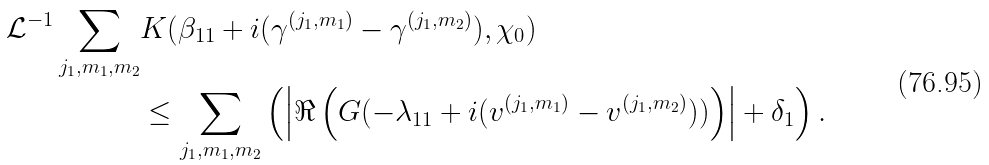<formula> <loc_0><loc_0><loc_500><loc_500>\mathcal { L } ^ { - 1 } \sum _ { j _ { 1 } , m _ { 1 } , m _ { 2 } } & K ( \beta _ { 1 1 } + i ( \gamma ^ { ( j _ { 1 } , m _ { 1 } ) } - \gamma ^ { ( j _ { 1 } , m _ { 2 } ) } ) , \chi _ { 0 } ) \\ & \leq \sum _ { j _ { 1 } , m _ { 1 } , m _ { 2 } } \left ( \left | \Re \left ( G ( - \lambda _ { 1 1 } + i ( v ^ { ( j _ { 1 } , m _ { 1 } ) } - v ^ { ( j _ { 1 } , m _ { 2 } ) } ) ) \right ) \right | + \delta _ { 1 } \right ) .</formula> 